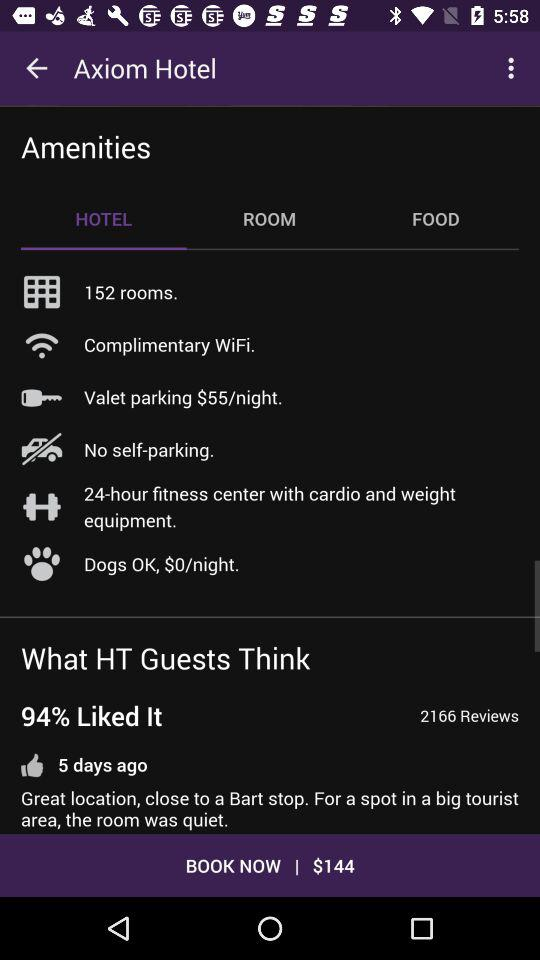What is the name of the hotel? The name of the hotel is "Axiom Hotel". 